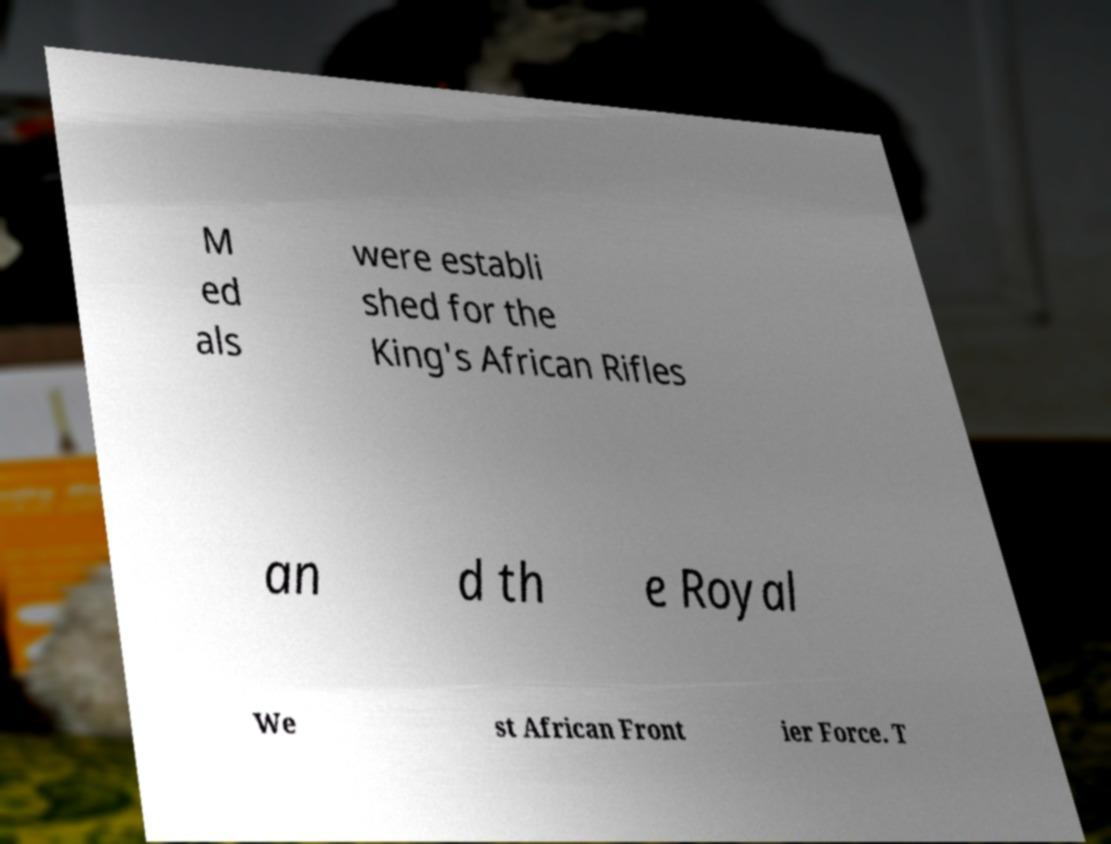Can you accurately transcribe the text from the provided image for me? M ed als were establi shed for the King's African Rifles an d th e Royal We st African Front ier Force. T 